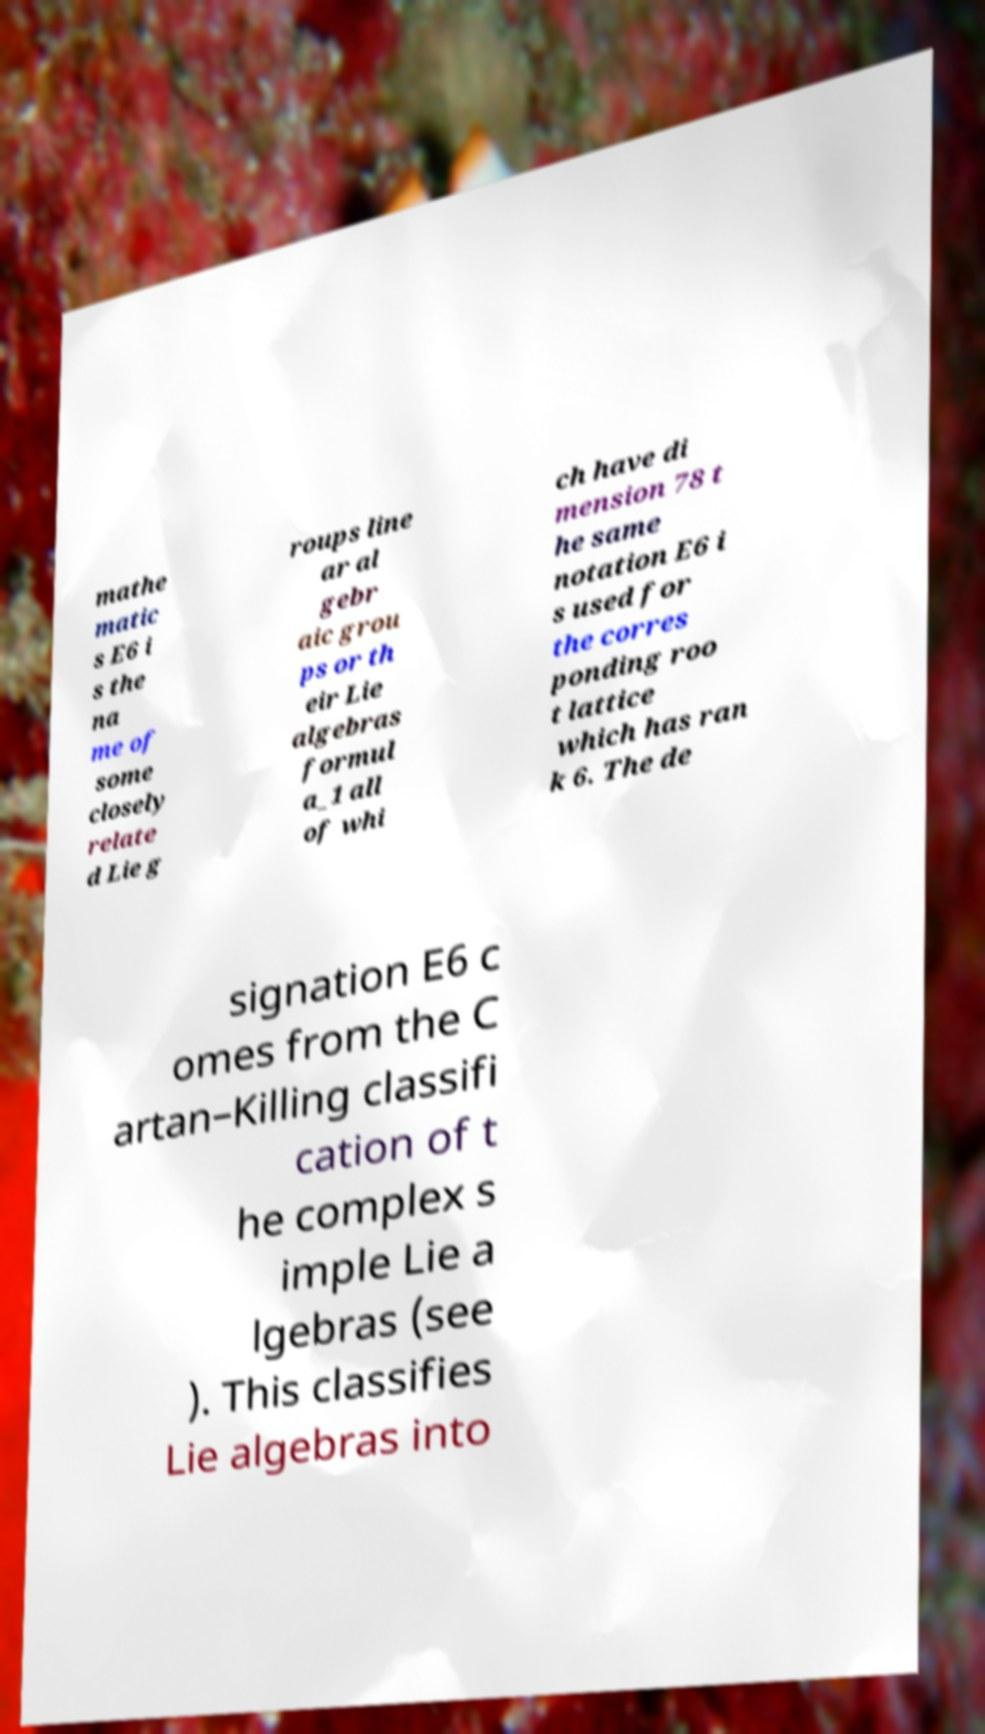Could you extract and type out the text from this image? mathe matic s E6 i s the na me of some closely relate d Lie g roups line ar al gebr aic grou ps or th eir Lie algebras formul a_1 all of whi ch have di mension 78 t he same notation E6 i s used for the corres ponding roo t lattice which has ran k 6. The de signation E6 c omes from the C artan–Killing classifi cation of t he complex s imple Lie a lgebras (see ). This classifies Lie algebras into 